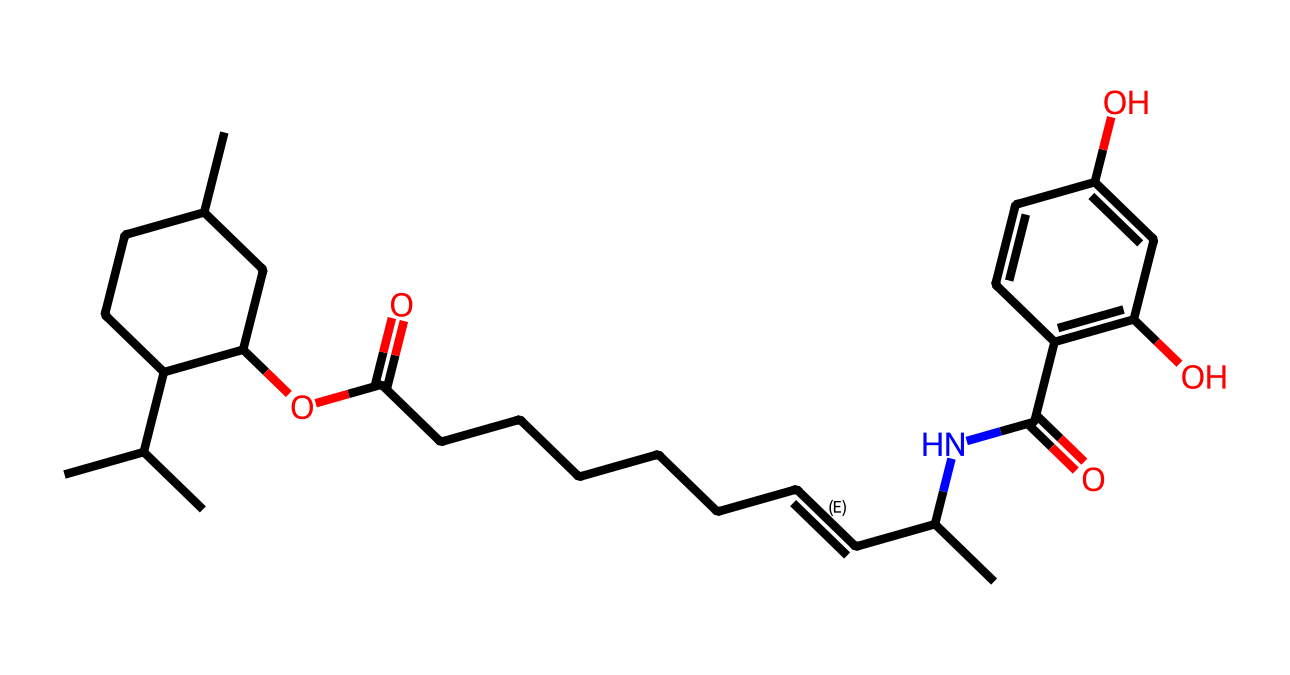What is the total number of carbon atoms in capsaicin? By visually inspecting the SMILES representation, we can count the number of 'C' atoms present. Each 'C' denotes a carbon atom, and there are 22 'C' symbols in this representation.
Answer: 22 How many nitrogen atoms are present in this chemical structure? In the provided SMILES, we look for 'N' to denote nitrogen atoms. There is one occurrence of 'N', indicating the presence of one nitrogen atom in the structure.
Answer: 1 What type of functional group is present in capsaicin? Examining the structure, we can identify the presence of an amide functional group, which is characterized by the carbonyl (C=O) attached to a nitrogen atom. This indicates the presence of an amide group in the overall structure.
Answer: amide What is the degree of unsaturation in capsaicin? To find the degree of unsaturation, we can count rings and double bonds. In the SMILES, there are 3 rings and 2 double bonds, providing a total of 5 degrees of unsaturation. The formula is (2C + 2 + N - H - X)/2, where we plug in values to verify this.
Answer: 5 Where in the structure do you find the ester functional group? The ester functional group is identified by the presence of a carbonyl (C=O) adjacent to an oxygen connected to another carbon. In the SMILES, 'OC(=O)' indicates that an ester group is present at that location in the molecular structure.
Answer: OC(=O) How many rings are present in the capsaicin structure? By examining the chemical structure as represented in the SMILES, we look for the numbers in the format 'C1', 'C2', etc., which indicate the start and end of rings. In total, there are three cyclic structures connected in this manner.
Answer: 3 